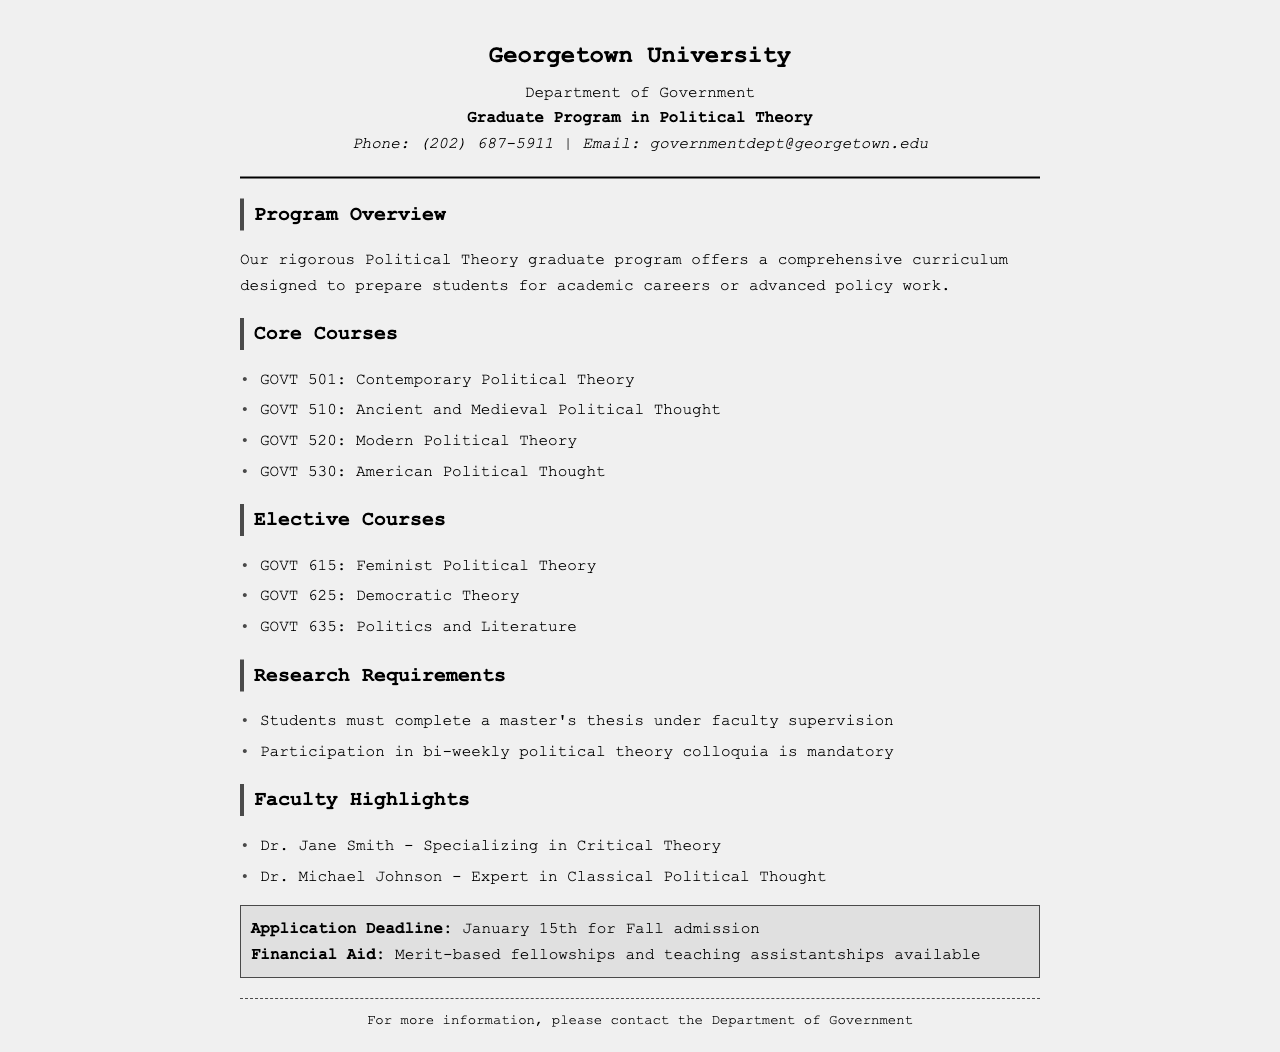What is the application deadline? The application deadline is specified in the document for Fall admission, which is January 15th.
Answer: January 15th Who is a faculty member specializing in Critical Theory? The faculty highlights section includes Dr. Jane Smith, who specializes in Critical Theory.
Answer: Dr. Jane Smith What course covers American Political Thought? The core courses section lists GOVT 530, which is focused on American Political Thought.
Answer: GOVT 530: American Political Thought Are there financial aid options available? The document highlights that merit-based fellowships and teaching assistantships are available as financial aid.
Answer: Merit-based fellowships and teaching assistantships How many core courses are listed in the document? The core courses section shows a total of four courses listed in the document.
Answer: Four What is the mandatory participation requirement for students? The research requirements state that participation in bi-weekly political theory colloquia is mandatory for students.
Answer: Participation in bi-weekly political theory colloquia Which course focuses on Feminist Political Theory? The elective courses section names GOVT 615, which focuses on Feminist Political Theory.
Answer: GOVT 615: Feminist Political Theory What department is the graduate program in? The document states that the program is under the Department of Government.
Answer: Department of Government 